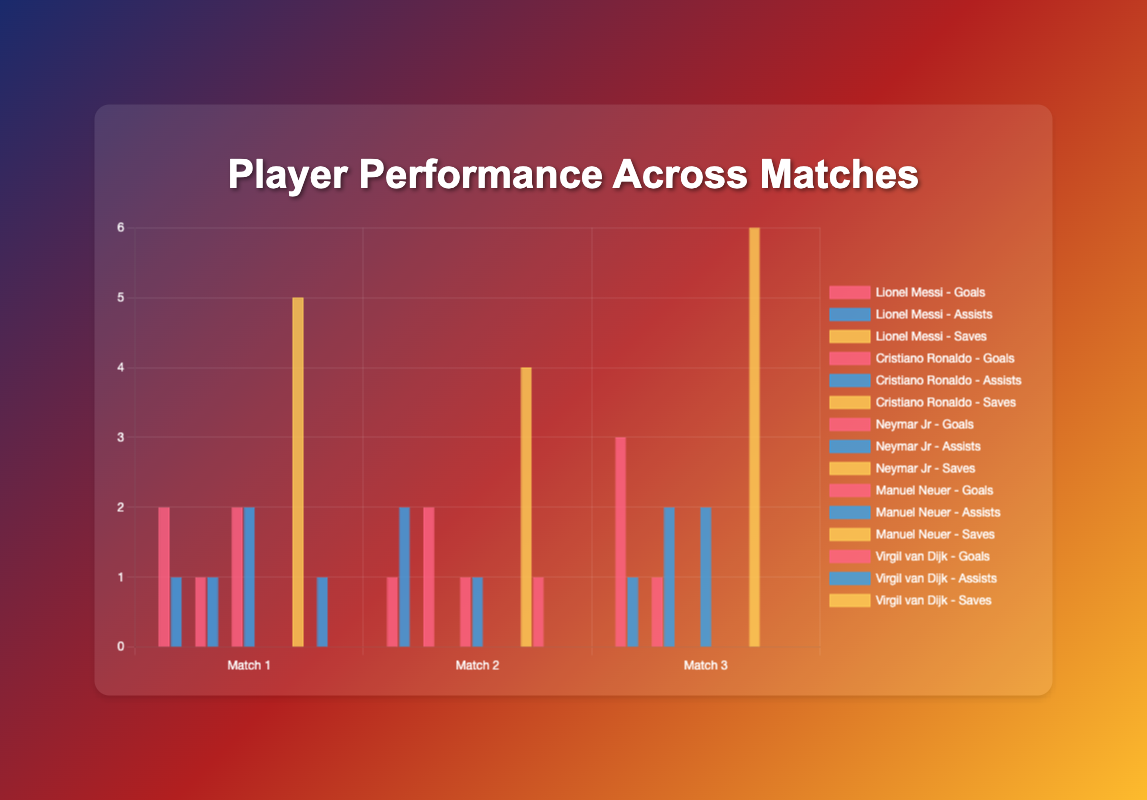How many goals did Lionel Messi and Cristiano Ronaldo score combined in Match 3? Lionel Messi scored 3 goals and Cristiano Ronaldo scored 1 goal in Match 3. The combined total is 3 + 1 = 4 goals.
Answer: 4 Which player had the highest number of saves in Match 1? Manuel Neuer had the highest number of saves in Match 1 with 5 saves.
Answer: Manuel Neuer Compare Neymar Jr’s and Lionel Messi’s total assists across all matches. Who had more assists? Neymar Jr had assists in Match 1 (2), Match 2 (1), and Match 3 (2), totaling 5. Lionel Messi had assists in Match 1 (1), Match 2 (2), and Match 3 (1), totaling 4. Neymar Jr had more assists.
Answer: Neymar Jr What is the difference in the total number of goals between Lionel Messi and Virgil van Dijk across all matches? Lionel Messi scored 2, 1, and 3 goals in Matches 1, 2, and 3 respectively, totaling 6. Virgil van Dijk scored 0, 1, and 0 goals in the respective matches, totaling 1. The difference is 6 - 1 = 5.
Answer: 5 Which match had the lowest number of goals scored by Neymar Jr? Neymar Jr scored 2 goals in Match 1, 1 goal in Match 2, and 0 goals in Match 3. The lowest number is in Match 3.
Answer: Match 3 How many more saves did Manuel Neuer make compared to Virgil van Dijk across all matches? Manuel Neuer made 5, 4, and 6 saves in Matches 1, 2, and 3 respectively, totaling 15. Virgil van Dijk made 0 saves in all matches. The difference is 15 - 0 = 15.
Answer: 15 In which match did Lionel Messi achieve his highest performance in terms of goals scored? Lionel Messi scored 2 goals in Match 1, 1 goal in Match 2, and 3 goals in Match 3. His highest performance in terms of goals was in Match 3.
Answer: Match 3 How many assists did all players combined make in Match 1? Lionel Messi had 1 assist, Cristiano Ronaldo had 1 assist, Neymar Jr had 2 assists, and Virgil van Dijk had 1 assist in Match 1. The total is 1 + 1 + 2 + 1 = 5 assists.
Answer: 5 